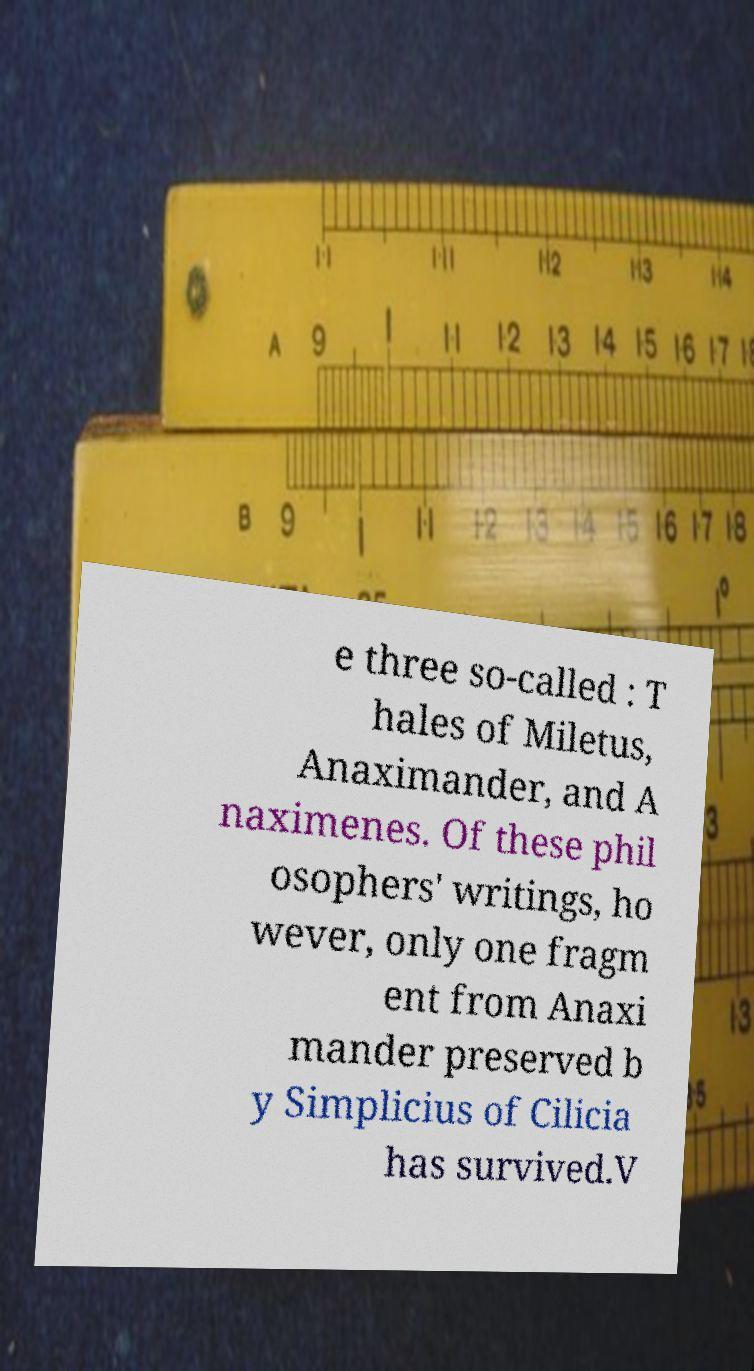Can you read and provide the text displayed in the image?This photo seems to have some interesting text. Can you extract and type it out for me? e three so-called : T hales of Miletus, Anaximander, and A naximenes. Of these phil osophers' writings, ho wever, only one fragm ent from Anaxi mander preserved b y Simplicius of Cilicia has survived.V 